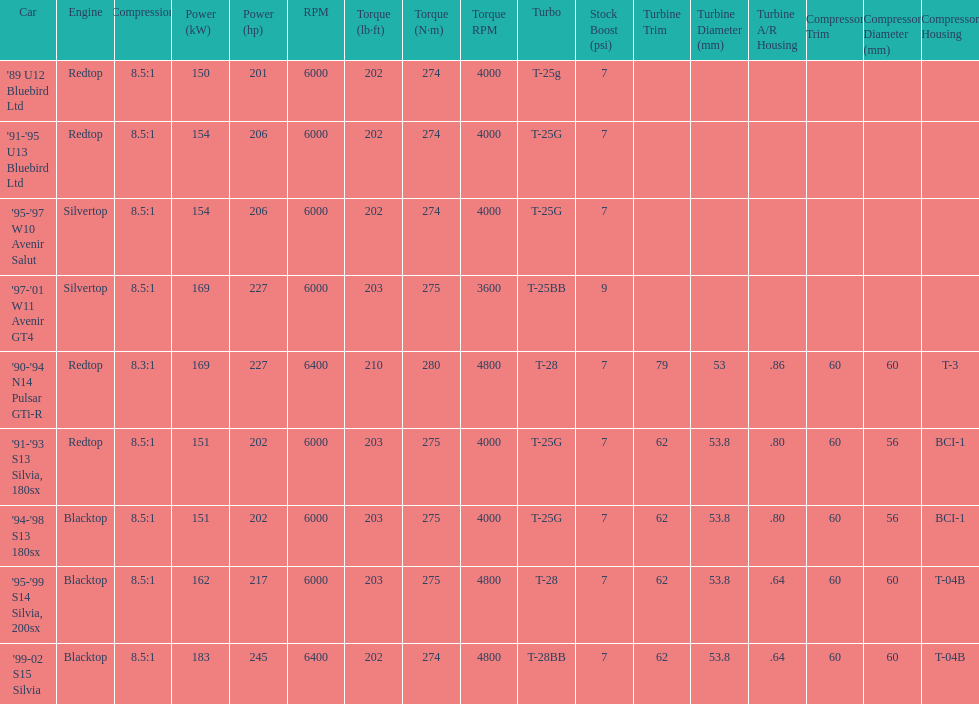Which engines are the same as the first entry ('89 u12 bluebird ltd)? '91-'95 U13 Bluebird Ltd, '90-'94 N14 Pulsar GTi-R, '91-'93 S13 Silvia, 180sx. 